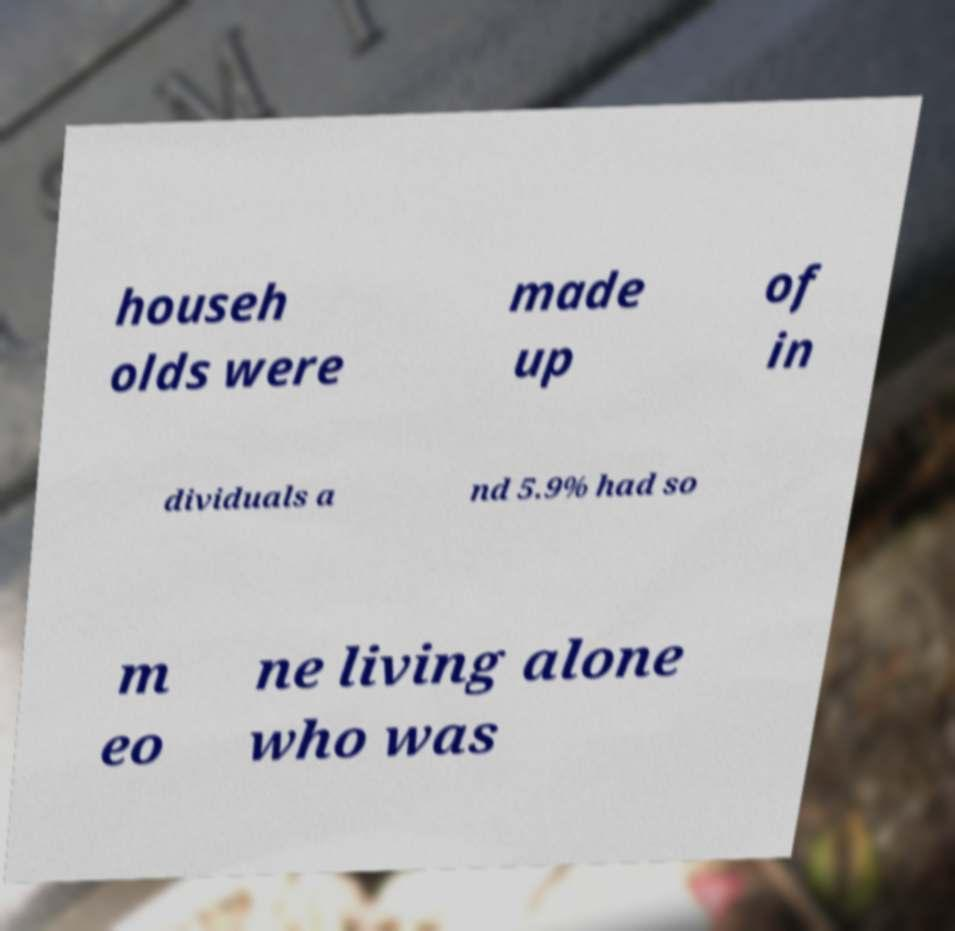For documentation purposes, I need the text within this image transcribed. Could you provide that? househ olds were made up of in dividuals a nd 5.9% had so m eo ne living alone who was 